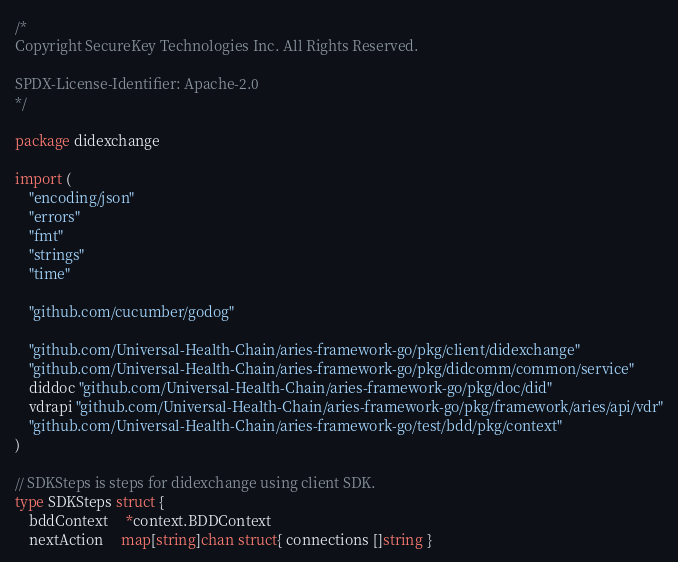<code> <loc_0><loc_0><loc_500><loc_500><_Go_>/*
Copyright SecureKey Technologies Inc. All Rights Reserved.

SPDX-License-Identifier: Apache-2.0
*/

package didexchange

import (
	"encoding/json"
	"errors"
	"fmt"
	"strings"
	"time"

	"github.com/cucumber/godog"

	"github.com/Universal-Health-Chain/aries-framework-go/pkg/client/didexchange"
	"github.com/Universal-Health-Chain/aries-framework-go/pkg/didcomm/common/service"
	diddoc "github.com/Universal-Health-Chain/aries-framework-go/pkg/doc/did"
	vdrapi "github.com/Universal-Health-Chain/aries-framework-go/pkg/framework/aries/api/vdr"
	"github.com/Universal-Health-Chain/aries-framework-go/test/bdd/pkg/context"
)

// SDKSteps is steps for didexchange using client SDK.
type SDKSteps struct {
	bddContext     *context.BDDContext
	nextAction     map[string]chan struct{ connections []string }</code> 